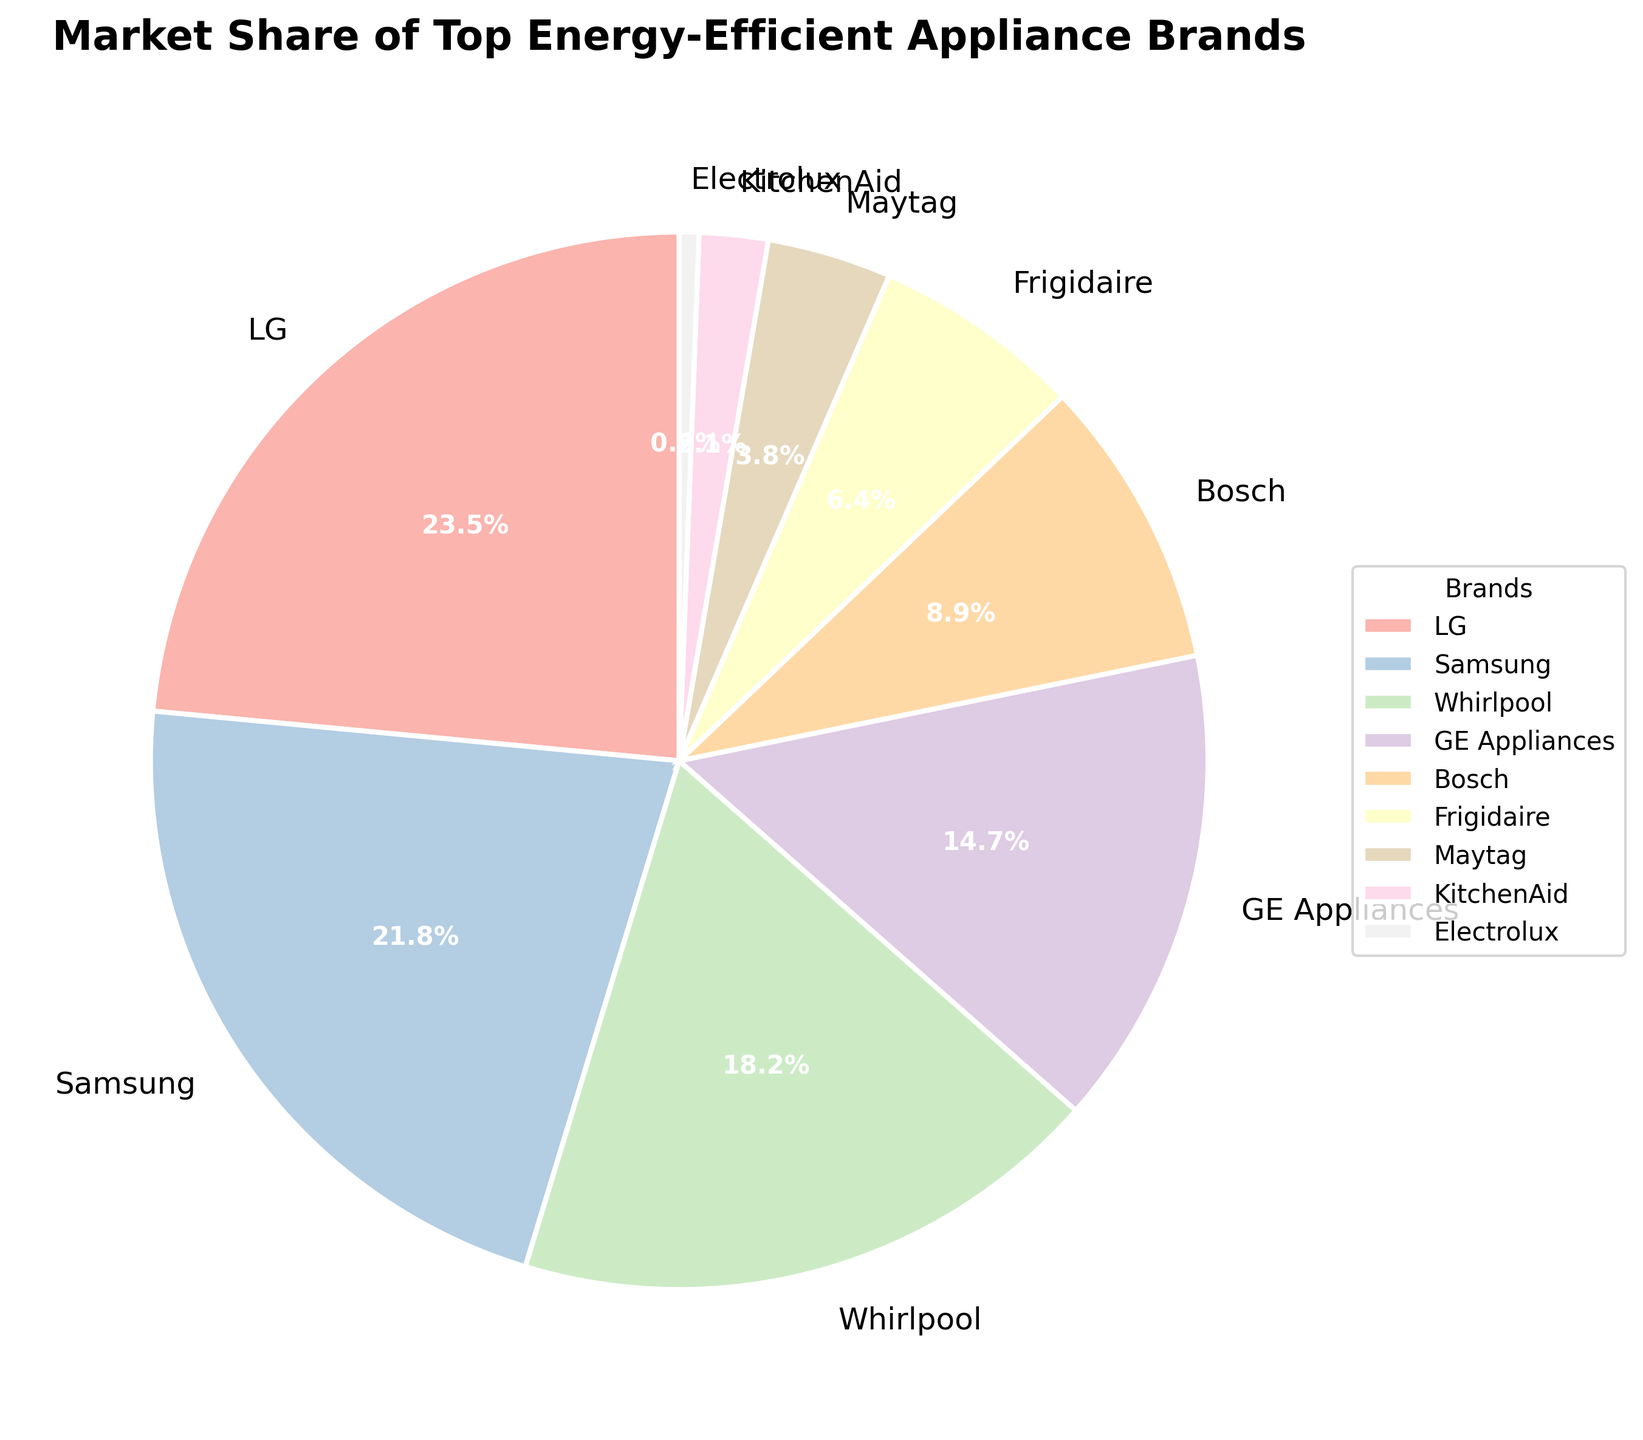Which brand has the largest market share? By observing the pie chart, the largest segment represents LG, with a market share of 23.5%
Answer: LG Which brand has the smallest market share? The smallest segment in the pie chart corresponds to Electrolux, with a market share of 0.6%
Answer: Electrolux How much greater is LG's market share compared to Bosch's? LG has a market share of 23.5%, and Bosch has a market share of 8.9%. The difference is 23.5% - 8.9% = 14.6%
Answer: 14.6% Combined, how much market share do LG and Samsung hold? Adding the market shares of LG (23.5%) and Samsung (21.8%) gives 23.5% + 21.8% = 45.3%
Answer: 45.3% What is the approximate proportion of market share between the top three brands (LG, Samsung, Whirlpool) and the rest? The top three brands (LG, Samsung, and Whirlpool) have market shares of 23.5%, 21.8%, and 18.2% respectively, summing to 63.5%. The rest account for 100% - 63.5% = 36.5%
Answer: 63.5% and 36.5% Which brands have a market share greater than 10%? From the pie chart, the brands with a market share greater than 10% are LG (23.5%), Samsung (21.8%), Whirlpool (18.2%), and GE Appliances (14.7%)
Answer: LG, Samsung, Whirlpool, GE Appliances How does the market share of KitchenAid compare to that of Frigidaire? Observing the pie chart, KitchenAid has a market share of 2.1%, while Frigidaire has a market share of 6.4%. Frigidaire’s market share is greater than KitchenAid’s by 6.4% - 2.1% = 4.3%
Answer: Frigidaire’s is 4.3% higher Is Bosch's market share closer to GE Appliances or Frigidaire? Bosch has a market share of 8.9%. GE Appliances has 14.7%, and Frigidaire has 6.4%. The difference between Bosch and GE Appliances is 14.7% - 8.9% = 5.8%, and between Bosch and Frigidaire is 8.9% - 6.4% = 2.5%. Therefore, Bosch's market share is closer to Frigidaire
Answer: Frigidaire What is the average market share of the bottom five brands? The bottom five brands are Bosch (8.9%), Frigidaire (6.4%), Maytag (3.8%), KitchenAid (2.1%), and Electrolux (0.6%). The sum is 8.9% + 6.4% + 3.8% + 2.1% + 0.6% = 21.8%. The average is 21.8% / 5 = 4.36%
Answer: 4.36% What percentage of the market do the brands with market share less than 5% hold? The brands with a market share less than 5% are Maytag (3.8%), KitchenAid (2.1%), and Electrolux (0.6%). Summing these gives 3.8% + 2.1% + 0.6% = 6.5%
Answer: 6.5% 